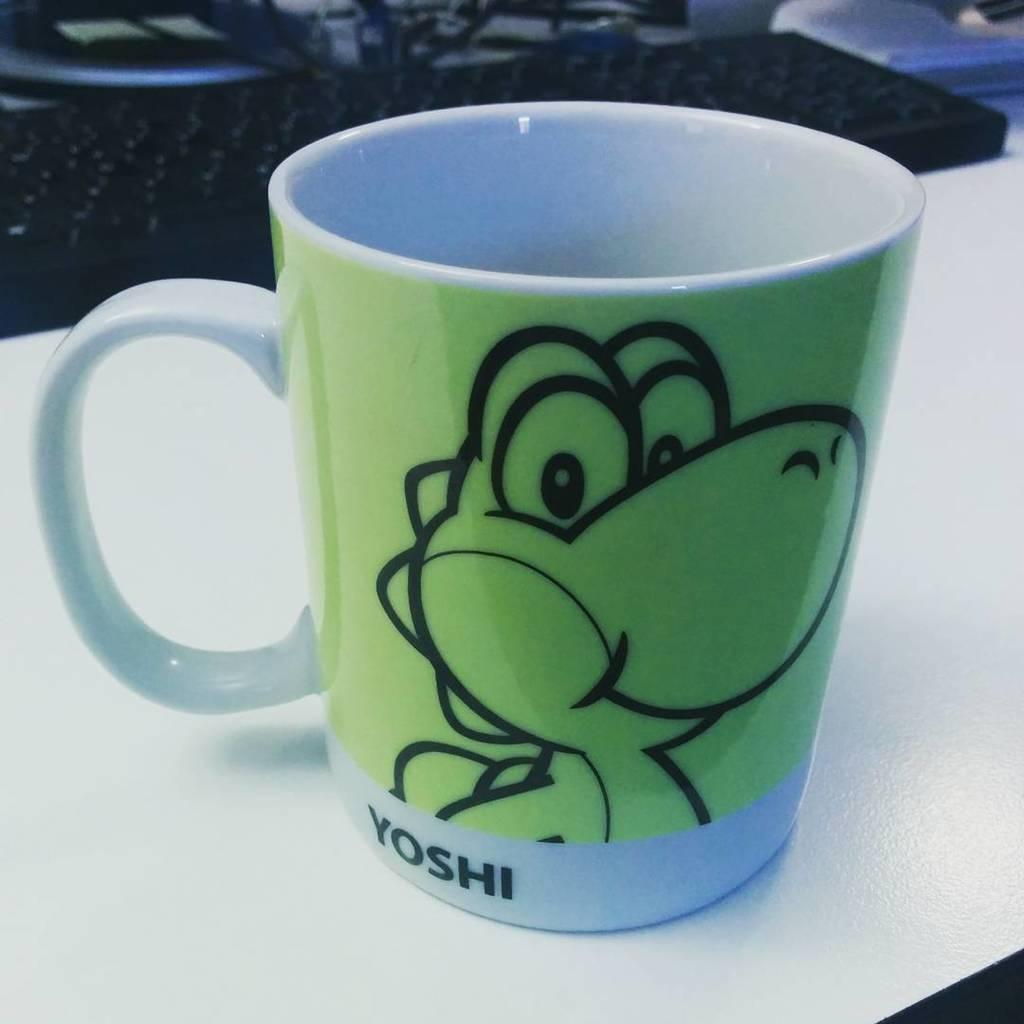What is the main object in the image with a design and text? There is a coffee mug with a design and text in the image. What is another object visible in the image? There is a keyboard in the image. What surface are the objects placed on in the image? There are objects on the table in the image. What type of feast is being prepared on the table in the image? There is no feast being prepared in the image; it only shows a coffee mug and a keyboard on a table. What chance does the person in the image have to win a prize? There is no indication of a prize or chance in the image; it only shows a coffee mug and a keyboard on a table. 